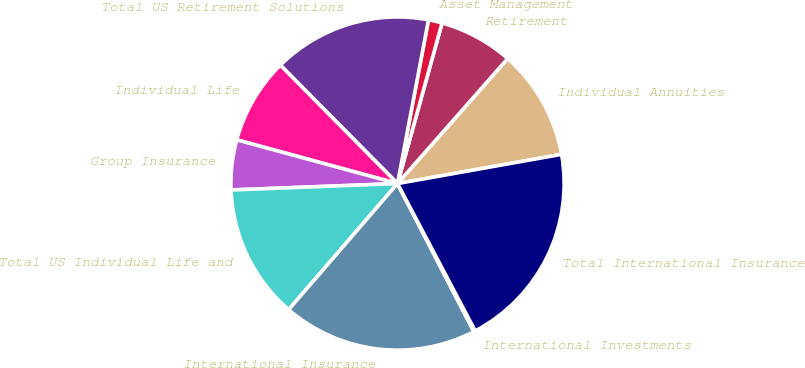Convert chart. <chart><loc_0><loc_0><loc_500><loc_500><pie_chart><fcel>Individual Annuities<fcel>Retirement<fcel>Asset Management<fcel>Total US Retirement Solutions<fcel>Individual Life<fcel>Group Insurance<fcel>Total US Individual Life and<fcel>International Insurance<fcel>International Investments<fcel>Total International Insurance<nl><fcel>10.7%<fcel>7.19%<fcel>1.33%<fcel>15.39%<fcel>8.36%<fcel>4.84%<fcel>13.05%<fcel>18.91%<fcel>0.15%<fcel>20.08%<nl></chart> 